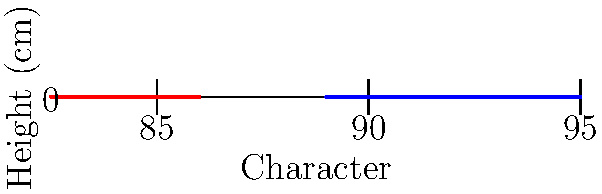In the graph above, which depicts the heights of male and female characters in fantasy novel illustrations, what is the average difference in height between male and female characters, and how might this representation challenge or reinforce gender stereotypes in fantasy literature? To answer this question, we need to follow these steps:

1. Calculate the average height for male characters:
   $$(180 + 185 + 190 + 178 + 182) / 5 = 183$$ cm

2. Calculate the average height for female characters:
   $$(165 + 170 + 168 + 172 + 167) / 5 = 168.4$$ cm

3. Calculate the difference between the average heights:
   $$183 - 168.4 = 14.6$$ cm

4. Analyze the representation:
   The graph shows a consistent height difference between male and female characters, with male characters being taller on average. This representation could be seen as reinforcing traditional gender stereotypes, where men are typically portrayed as physically larger and stronger than women.

5. Consider challenging stereotypes:
   From the perspective of a young reader inspired to challenge gender stereotypes, this representation raises questions about the diversity of body types in fantasy literature. It prompts consideration of how authors and illustrators might create more varied and less stereotypical physical representations of characters, regardless of gender.

6. Reflect on impact:
   The consistent height difference might influence readers' perceptions of gender roles and physical capabilities in fantasy worlds. By recognizing this pattern, readers can critically examine how physical attributes are used to convey character traits and question whether these representations limit or expand the roles available to characters of different genders.
Answer: 14.6 cm difference; reinforces stereotypes by consistently depicting males as taller, challenging readers to question diverse body representation in fantasy. 